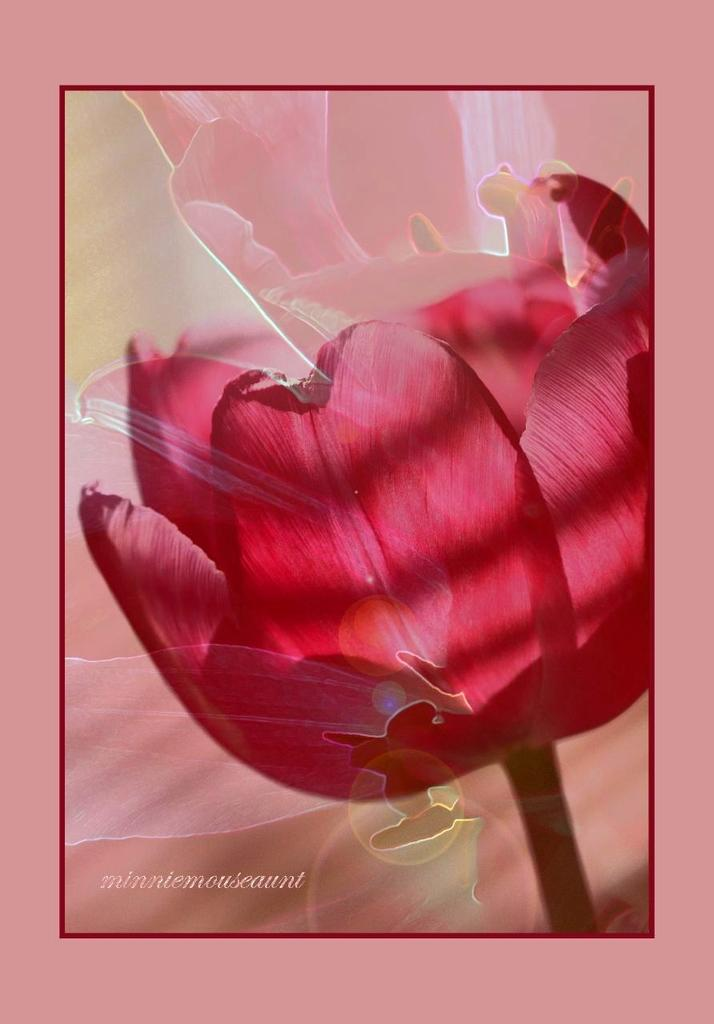What is the main subject of the poster in the image? The main subject of the poster is a flower. What color is the flower on the poster? The flower is in pink color. Is there a veil covering the flower in the image? No, there is no veil present in the image; the flower is visible and not covered. How many snakes are wrapped around the stem of the flower in the image? There are no snakes present in the image; the flower is depicted alone. 